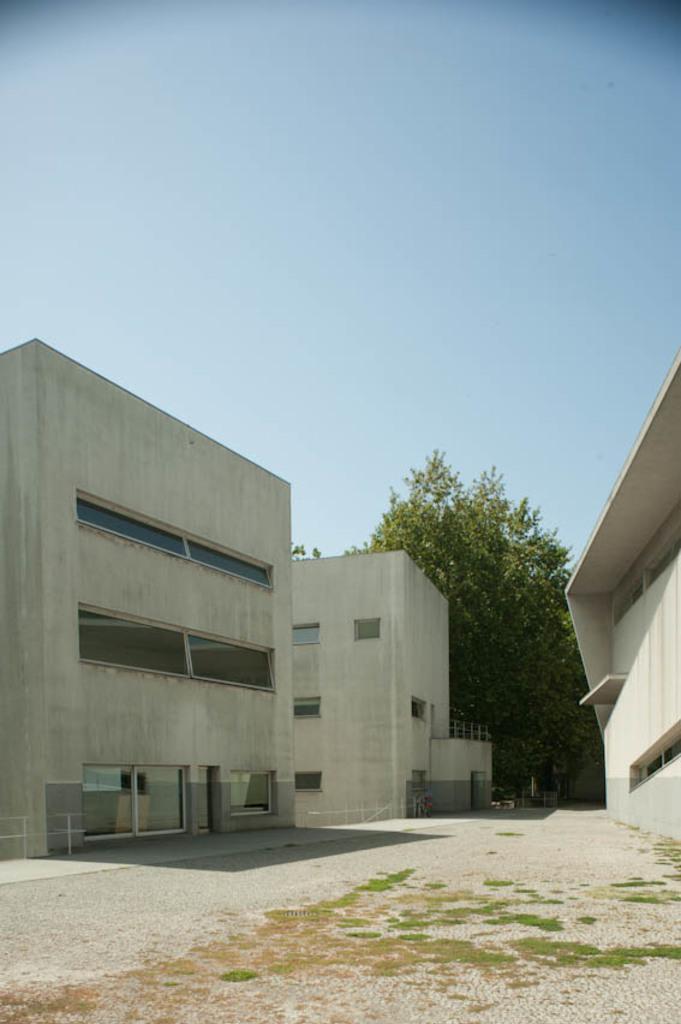In one or two sentences, can you explain what this image depicts? Here we can see buildings and trees. In the background there is sky. 